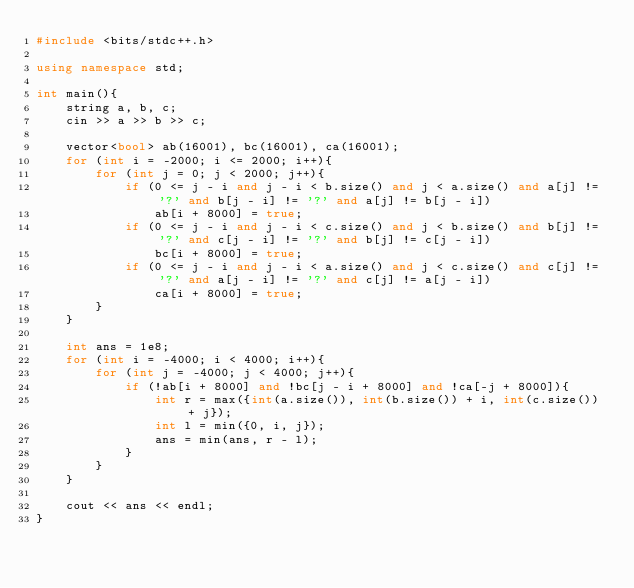Convert code to text. <code><loc_0><loc_0><loc_500><loc_500><_C++_>#include <bits/stdc++.h>

using namespace std;

int main(){
    string a, b, c;
    cin >> a >> b >> c;
    
    vector<bool> ab(16001), bc(16001), ca(16001);
    for (int i = -2000; i <= 2000; i++){
        for (int j = 0; j < 2000; j++){
            if (0 <= j - i and j - i < b.size() and j < a.size() and a[j] != '?' and b[j - i] != '?' and a[j] != b[j - i])
                ab[i + 8000] = true;
            if (0 <= j - i and j - i < c.size() and j < b.size() and b[j] != '?' and c[j - i] != '?' and b[j] != c[j - i])
                bc[i + 8000] = true;
            if (0 <= j - i and j - i < a.size() and j < c.size() and c[j] != '?' and a[j - i] != '?' and c[j] != a[j - i])
                ca[i + 8000] = true;
        }
    }

    int ans = 1e8;
    for (int i = -4000; i < 4000; i++){
        for (int j = -4000; j < 4000; j++){
            if (!ab[i + 8000] and !bc[j - i + 8000] and !ca[-j + 8000]){
                int r = max({int(a.size()), int(b.size()) + i, int(c.size()) + j});
                int l = min({0, i, j});
                ans = min(ans, r - l);
            }
        }
    }

    cout << ans << endl;
}</code> 